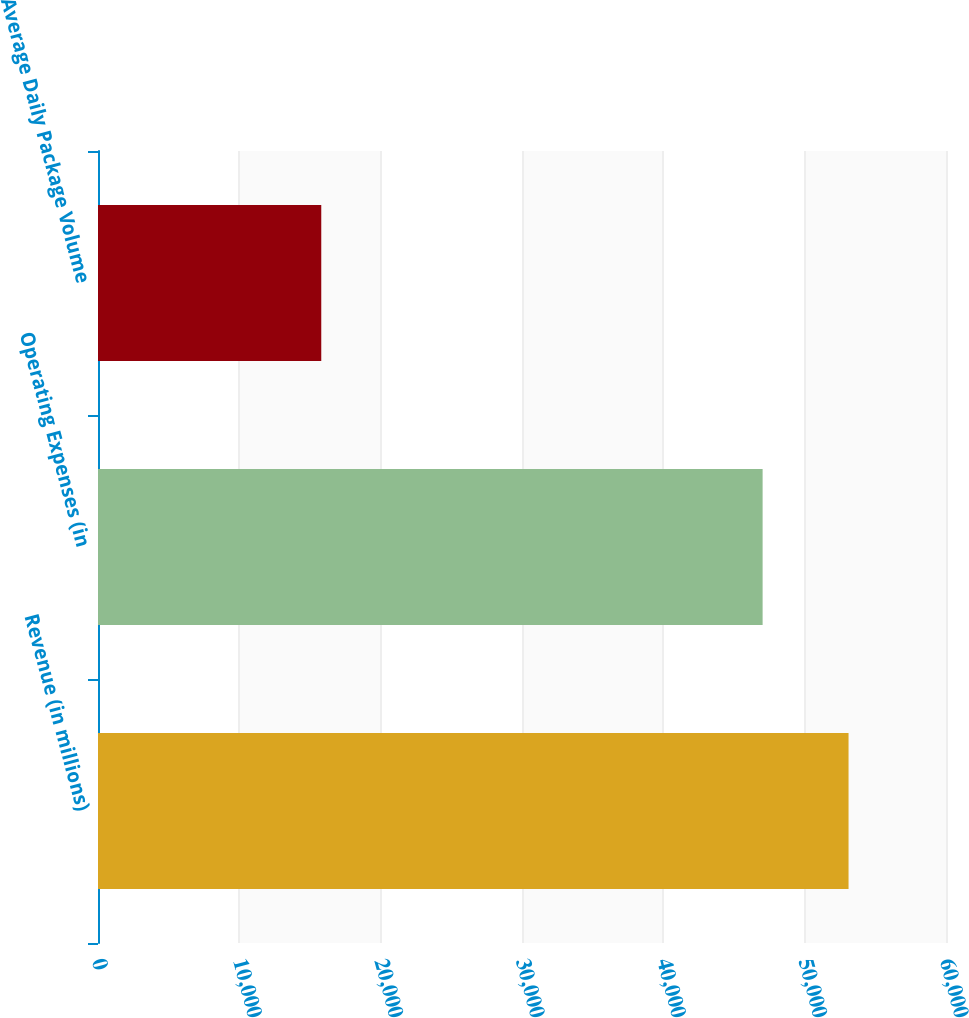Convert chart to OTSL. <chart><loc_0><loc_0><loc_500><loc_500><bar_chart><fcel>Revenue (in millions)<fcel>Operating Expenses (in<fcel>Average Daily Package Volume<nl><fcel>53105<fcel>47025<fcel>15797<nl></chart> 